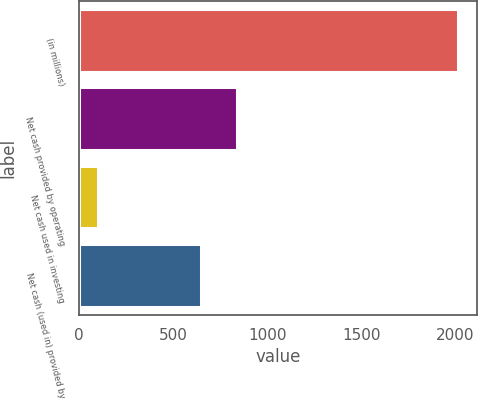Convert chart. <chart><loc_0><loc_0><loc_500><loc_500><bar_chart><fcel>(in millions)<fcel>Net cash provided by operating<fcel>Net cash used in investing<fcel>Net cash (used in) provided by<nl><fcel>2015<fcel>839.66<fcel>99.4<fcel>648.1<nl></chart> 